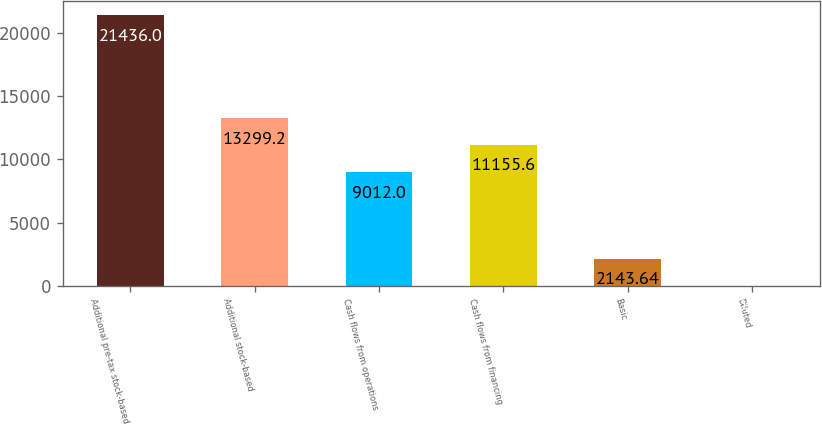<chart> <loc_0><loc_0><loc_500><loc_500><bar_chart><fcel>Additional pre-tax stock-based<fcel>Additional stock-based<fcel>Cash flows from operations<fcel>Cash flows from financing<fcel>Basic<fcel>Diluted<nl><fcel>21436<fcel>13299.2<fcel>9012<fcel>11155.6<fcel>2143.64<fcel>0.04<nl></chart> 